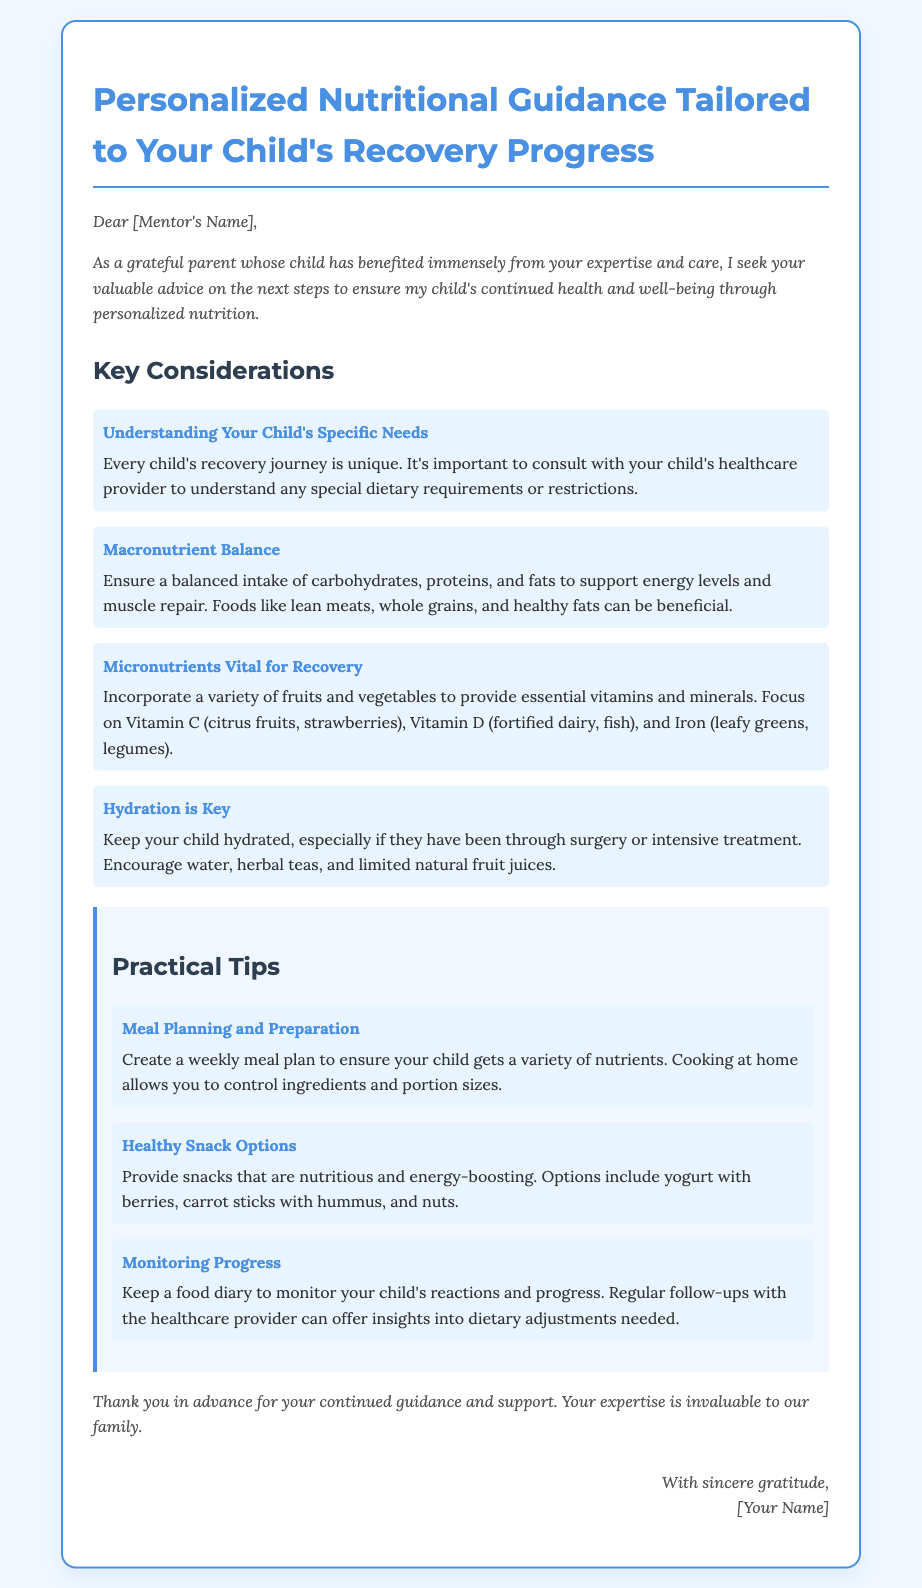What is the title of the document? The title appears at the top of the document, summarizing its content.
Answer: Personalized Nutritional Guidance Tailored to Your Child's Recovery Progress Who is the audience of the document? The introduction specifies who the intended recipient is and expresses gratitude.
Answer: [Mentor's Name] What are the four key considerations mentioned? These considerations are listed under the "Key Considerations" section.
Answer: Understanding Your Child's Specific Needs, Macronutrient Balance, Micronutrients Vital for Recovery, Hydration is Key How many practical tips are provided? The practical tips are listed under the "Practical Tips" section, which contains three items.
Answer: 3 What food is mentioned for Vitamin C? The document provides examples of foods high in specific vitamins in the micronutrients section.
Answer: Citrus fruits What is suggested for healthy snacks? The document gives ideas for nutritious snacks to consider for a child.
Answer: Yogurt with berries What type of document is this? The format and content suggest a letter seeking advice.
Answer: Envelope What is advised to help monitor progress? The document recommends a specific method for keeping track of dietary changes and effects.
Answer: Food diary 